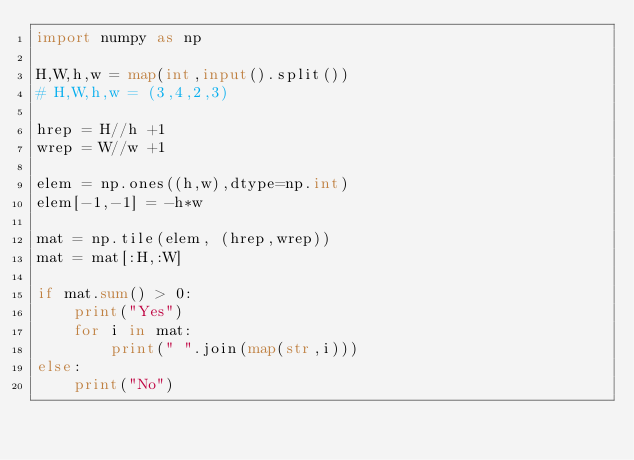Convert code to text. <code><loc_0><loc_0><loc_500><loc_500><_Python_>import numpy as np

H,W,h,w = map(int,input().split())
# H,W,h,w = (3,4,2,3)

hrep = H//h +1
wrep = W//w +1

elem = np.ones((h,w),dtype=np.int)
elem[-1,-1] = -h*w

mat = np.tile(elem, (hrep,wrep))
mat = mat[:H,:W]

if mat.sum() > 0:
	print("Yes")
	for i in mat:
		print(" ".join(map(str,i)))
else:
	print("No")</code> 